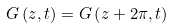<formula> <loc_0><loc_0><loc_500><loc_500>G \left ( z , t \right ) = G \left ( z + 2 \pi , t \right )</formula> 